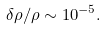Convert formula to latex. <formula><loc_0><loc_0><loc_500><loc_500>\delta \rho / \rho \sim 1 0 ^ { - 5 } .</formula> 